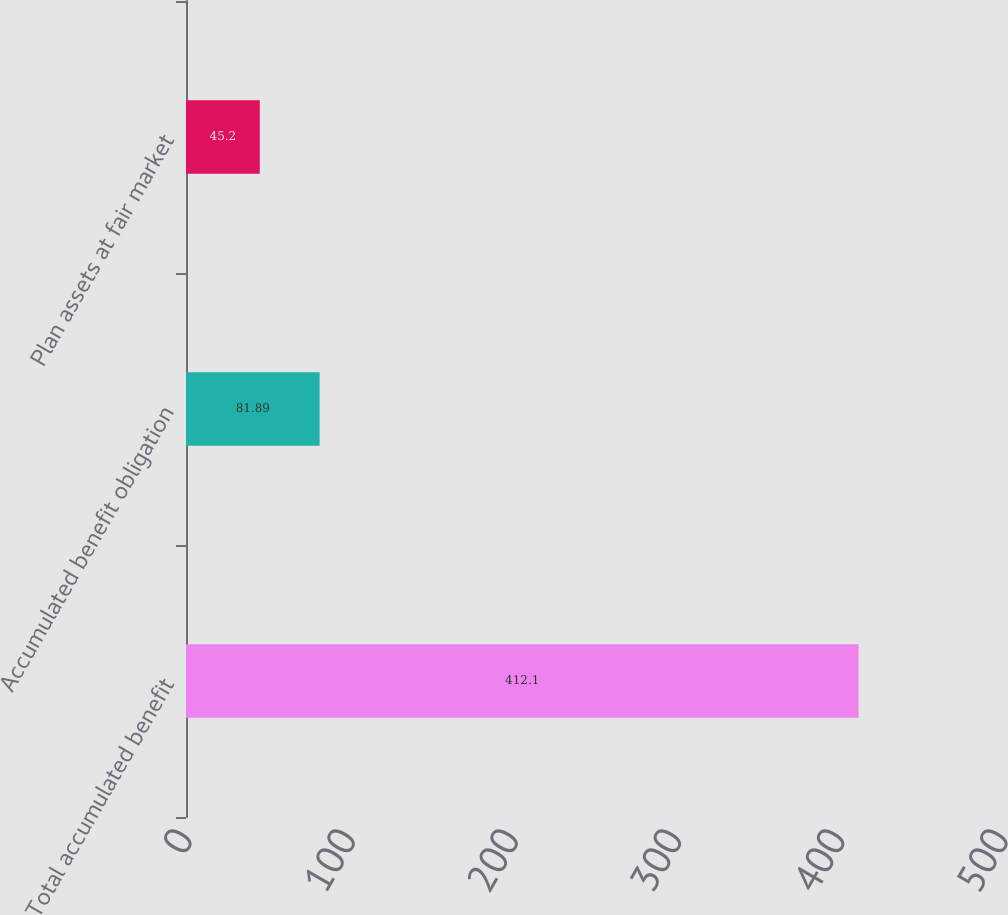Convert chart to OTSL. <chart><loc_0><loc_0><loc_500><loc_500><bar_chart><fcel>Total accumulated benefit<fcel>Accumulated benefit obligation<fcel>Plan assets at fair market<nl><fcel>412.1<fcel>81.89<fcel>45.2<nl></chart> 